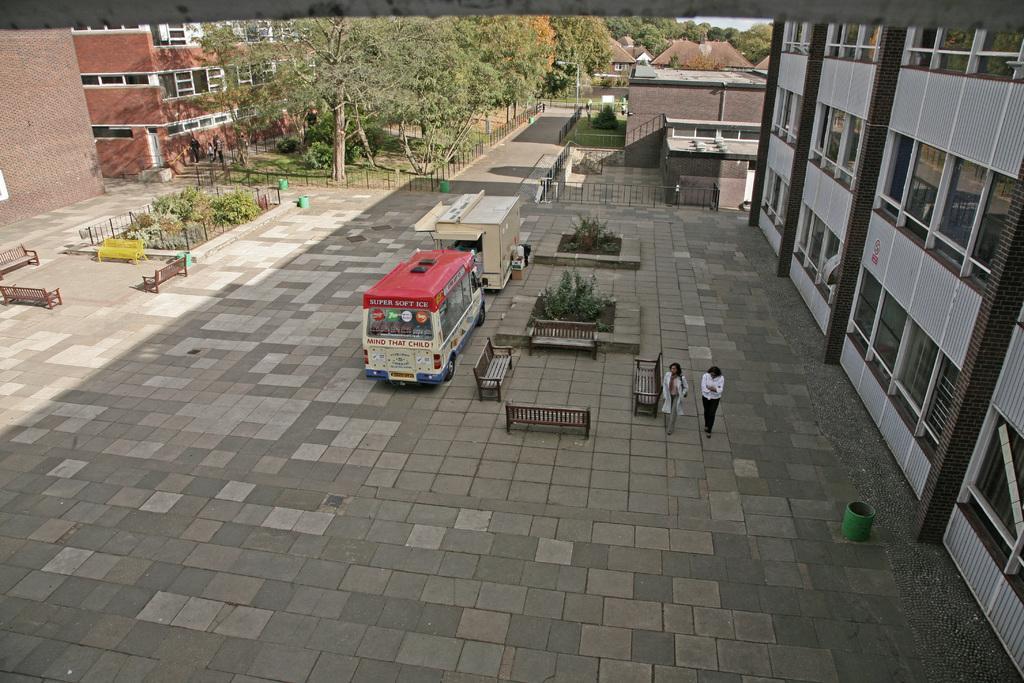Could you give a brief overview of what you see in this image? In this picture we can see there are two people walking on the walkway. On the right side of the image, there is a building. On the left side of the people there are benches, vehicles, plants and some objects. Behind the vehicles there are iron grilles, buildings and trees. At the top of the image there is the sky. 